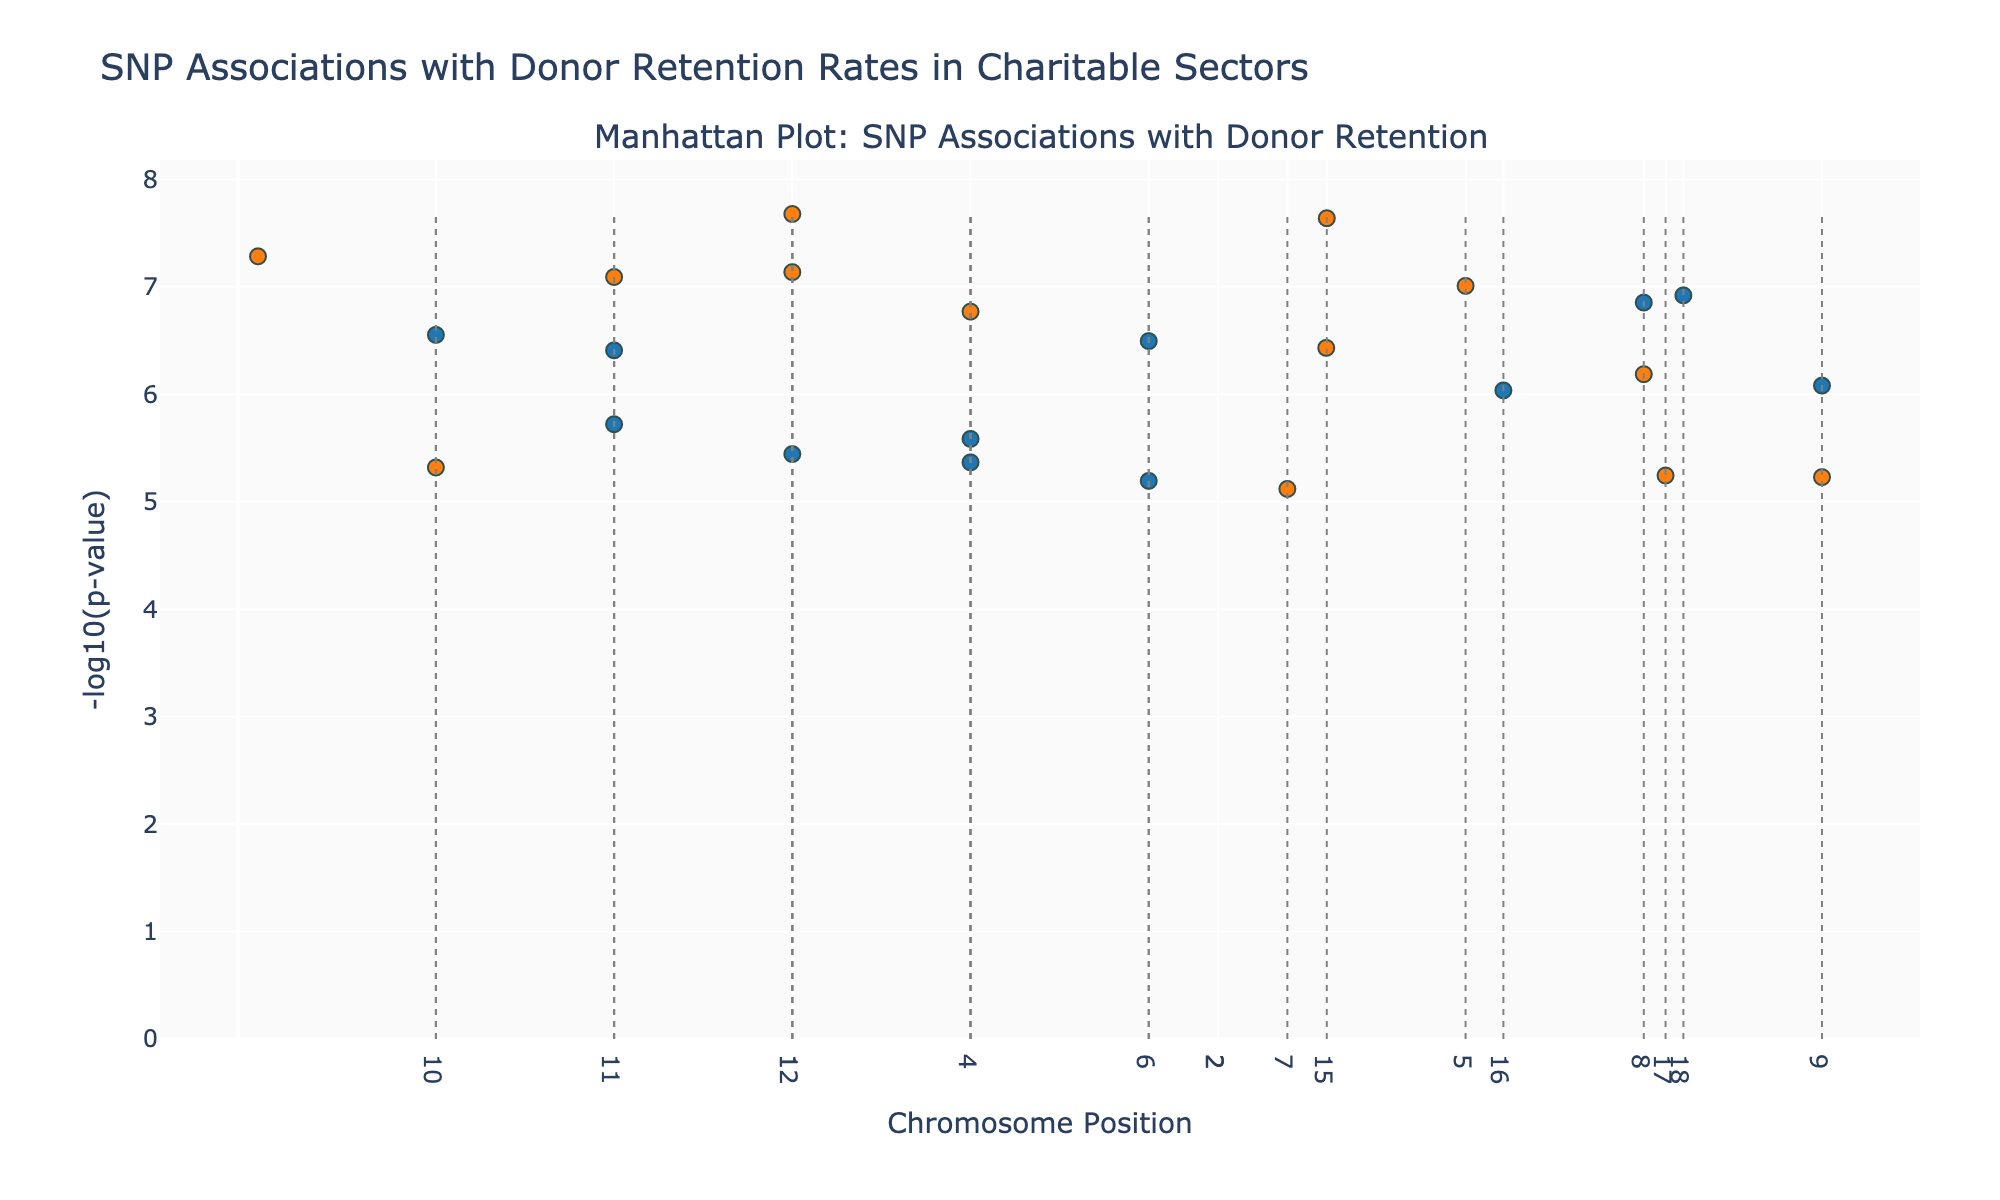What is the title of the figure? The title of the figure is usually prominently displayed and summarizes the main topic or focus. In this case, it is located at the top of the figure and reads "SNP Associations with Donor Retention Rates in Charitable Sectors".
Answer: SNP Associations with Donor Retention Rates in Charitable Sectors Which sector's SNP has the smallest p-value? To determine the sector with the smallest p-value, look for the data point with the highest -log10(p-value), which is represented as a peak on the y-axis. According to the plot, the highest peak corresponds to the SNP rs2476601 associated with the Education sector.
Answer: Education How many SNPs have a p-value less than 1e-7? Counting the number of data points that are above the -log10(1e-7) threshold, which is 7, helps identify SNPs with p-values less than 1e-7.
Answer: 7 Which chromosomes have more significant SNPs, odd or even? Summing up the number of significant SNPs (higher peaks) for odd-numbered and even-numbered chromosomes separately, it is observed that even-numbered chromosomes host more significant SNPs.
Answer: Even What is the range of -log10(p-values) in the plot? The highest -log10(p-value) represents the most significant SNP, and the lowest represents the least significant. By noting the highest and lowest points on the y-axis, it's clear that the range is from approximately 5 (smallest) to 8 (largest).
Answer: 5 to 8 Which sector has the SNP rs429358 with significant association, and what is its chromosome number? By hovering over the point representing rs429358, the sector (Religious) and chromosome number (5) are displayed.
Answer: Religious, Chromosome 5 Compare the highest -log10(p-value) between SNPs associated with healthcare and disaster relief. Which one is higher? By locating the peak associated with Healthcare (rs11209026) and comparing it to the peak associated with Disaster Relief (rs1801133), it's apparent that Healthcare's peak is lower than Disaster Relief's. Hence, the -log10(p-value) for Disaster Relief is higher.
Answer: Disaster Relief What is the chromosome number that separates the data points between SNP rs11209026 and rs1800896? Identifying the positions of rs11209026 (Chromosome 1) and rs1800896 (Chromosome 2) and noting the gap in the x-axis between them reveals that Chromosome 1 and 2 demarcation occurs between these SNPs.
Answer: Chromosome 1 